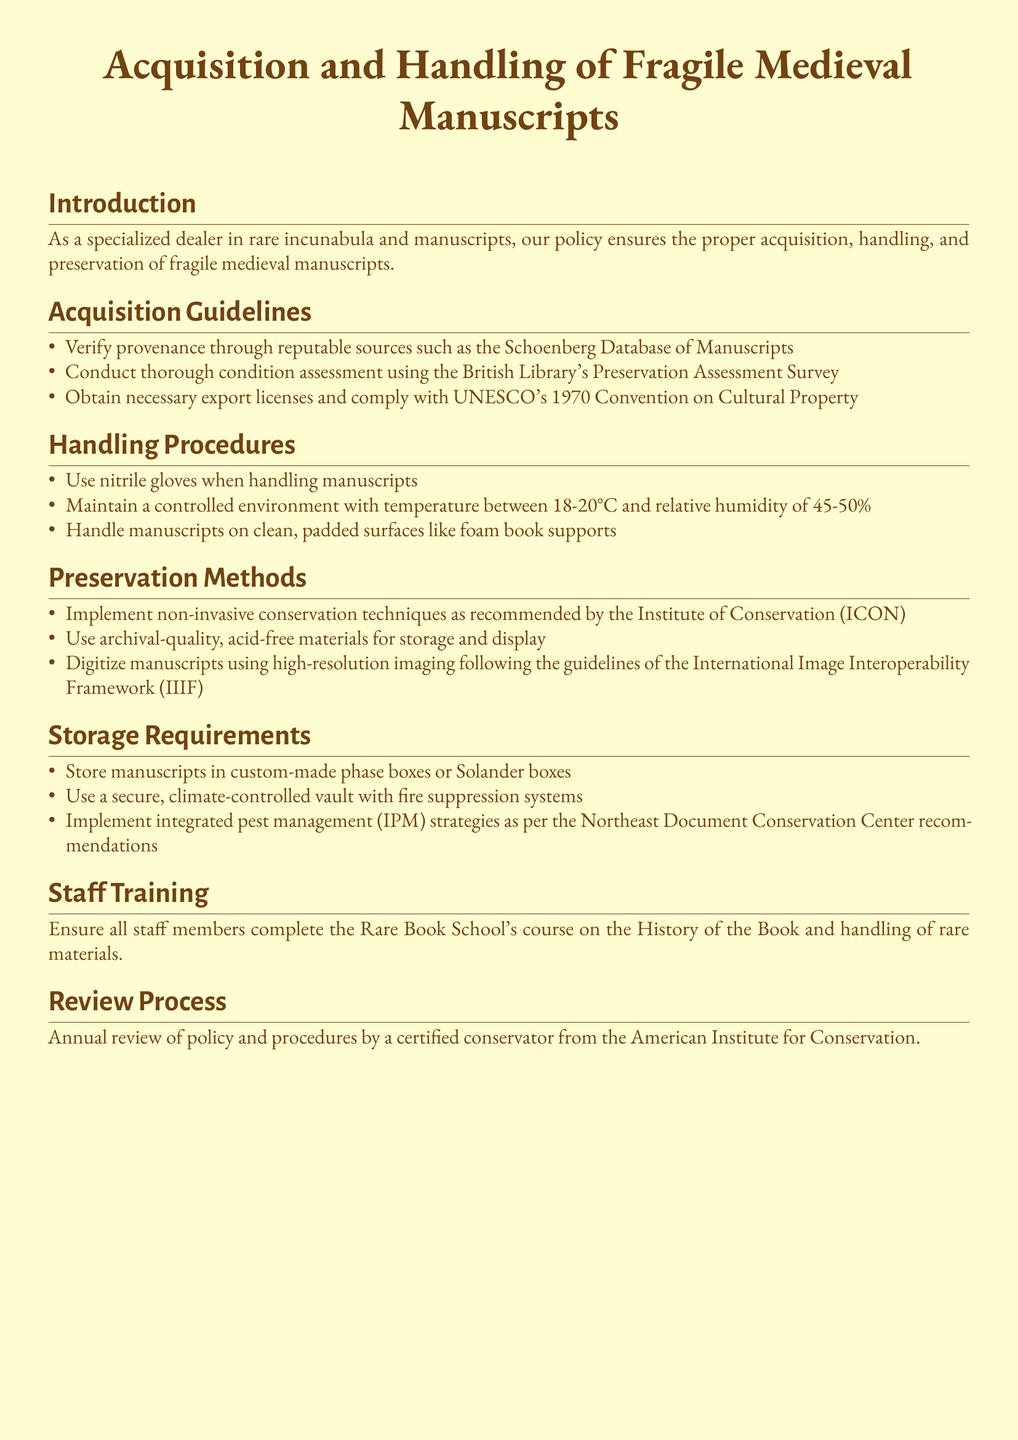What is the temperature range for handling manuscripts? The document states that the temperature range for handling manuscripts should be between 18-20°C.
Answer: 18-20°C What type of gloves should be used when handling manuscripts? The handling procedures specify the use of nitrile gloves when handling manuscripts.
Answer: Nitrile gloves Which organization’s survey is recommended for condition assessment? The document mentions the British Library's Preservation Assessment Survey for condition assessment.
Answer: British Library What type of materials should be used for storage? The preservation methods recommend using archival-quality, acid-free materials for storage.
Answer: Archival-quality, acid-free materials What is the humidity range for handling manuscripts? The document specifies that relative humidity should be between 45-50%.
Answer: 45-50% Who conducts the annual review of policy and procedures? The policy states that a certified conservator from the American Institute for Conservation conducts the annual review.
Answer: American Institute for Conservation What type of box is recommended for manuscript storage? The storage requirements recommend custom-made phase boxes or Solander boxes.
Answer: Phase boxes or Solander boxes What course should staff complete for training? The document states that staff members should complete the Rare Book School's course on the History of the Book.
Answer: Rare Book School's course What is the purpose of implementing integrated pest management strategies? The document refers to pest management strategies for preserving manuscripts as per recommendations.
Answer: Preserve manuscripts 